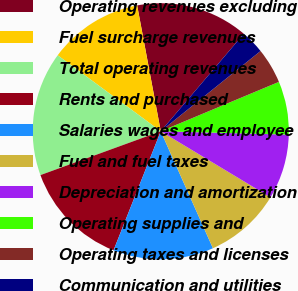<chart> <loc_0><loc_0><loc_500><loc_500><pie_chart><fcel>Operating revenues excluding<fcel>Fuel surcharge revenues<fcel>Total operating revenues<fcel>Rents and purchased<fcel>Salaries wages and employee<fcel>Fuel and fuel taxes<fcel>Depreciation and amortization<fcel>Operating supplies and<fcel>Operating taxes and licenses<fcel>Communication and utilities<nl><fcel>14.18%<fcel>11.94%<fcel>15.67%<fcel>13.43%<fcel>12.69%<fcel>9.7%<fcel>8.21%<fcel>6.72%<fcel>4.48%<fcel>2.99%<nl></chart> 